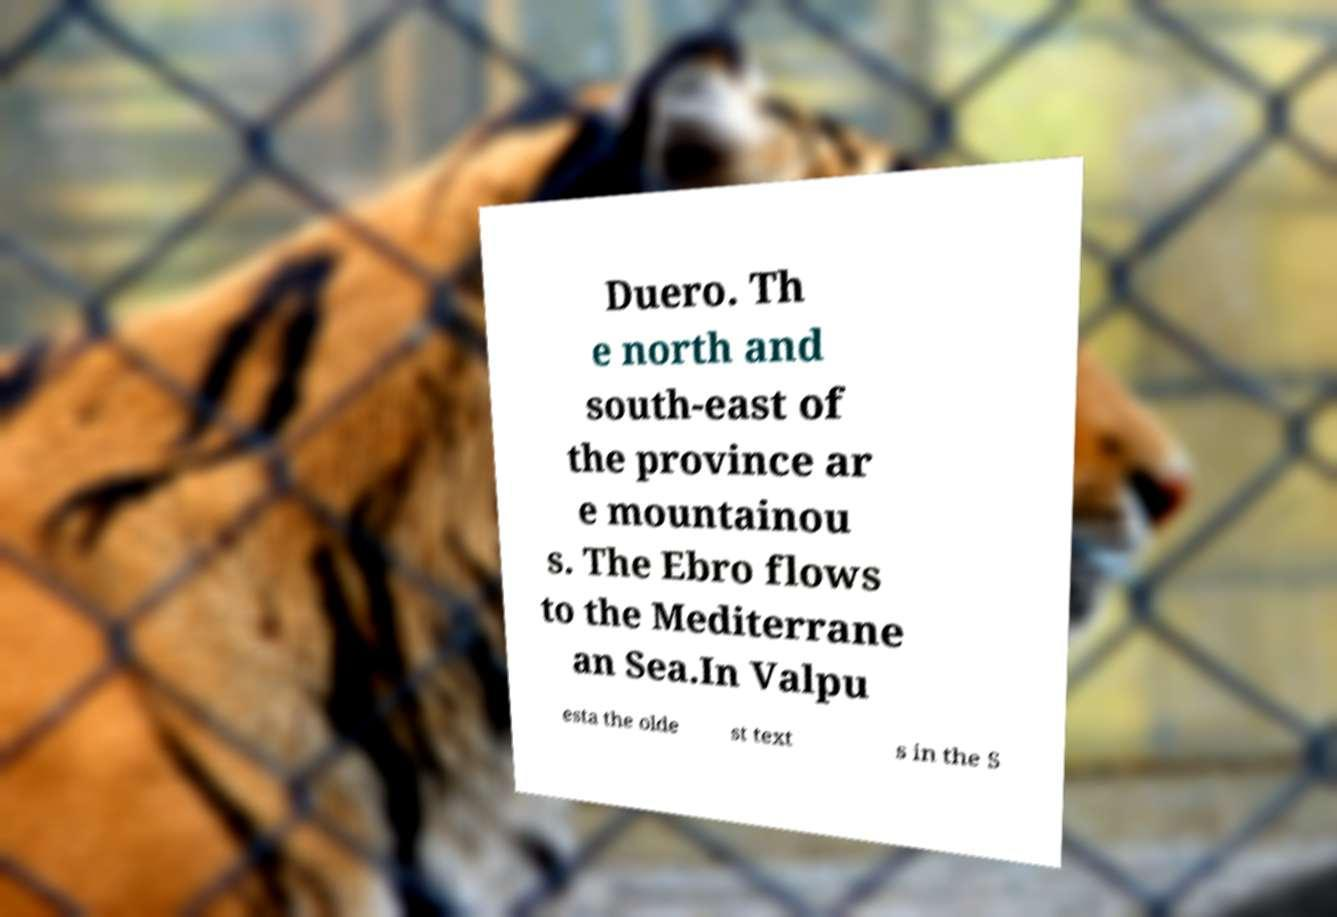Can you accurately transcribe the text from the provided image for me? Duero. Th e north and south-east of the province ar e mountainou s. The Ebro flows to the Mediterrane an Sea.In Valpu esta the olde st text s in the S 